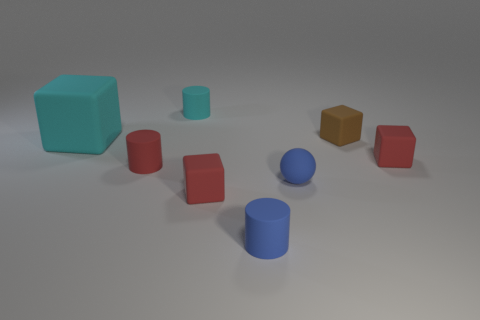Add 2 small blue things. How many objects exist? 10 Subtract all purple balls. Subtract all gray blocks. How many balls are left? 1 Subtract all spheres. How many objects are left? 7 Subtract 0 yellow spheres. How many objects are left? 8 Subtract all balls. Subtract all small gray matte balls. How many objects are left? 7 Add 6 brown rubber things. How many brown rubber things are left? 7 Add 3 tiny blocks. How many tiny blocks exist? 6 